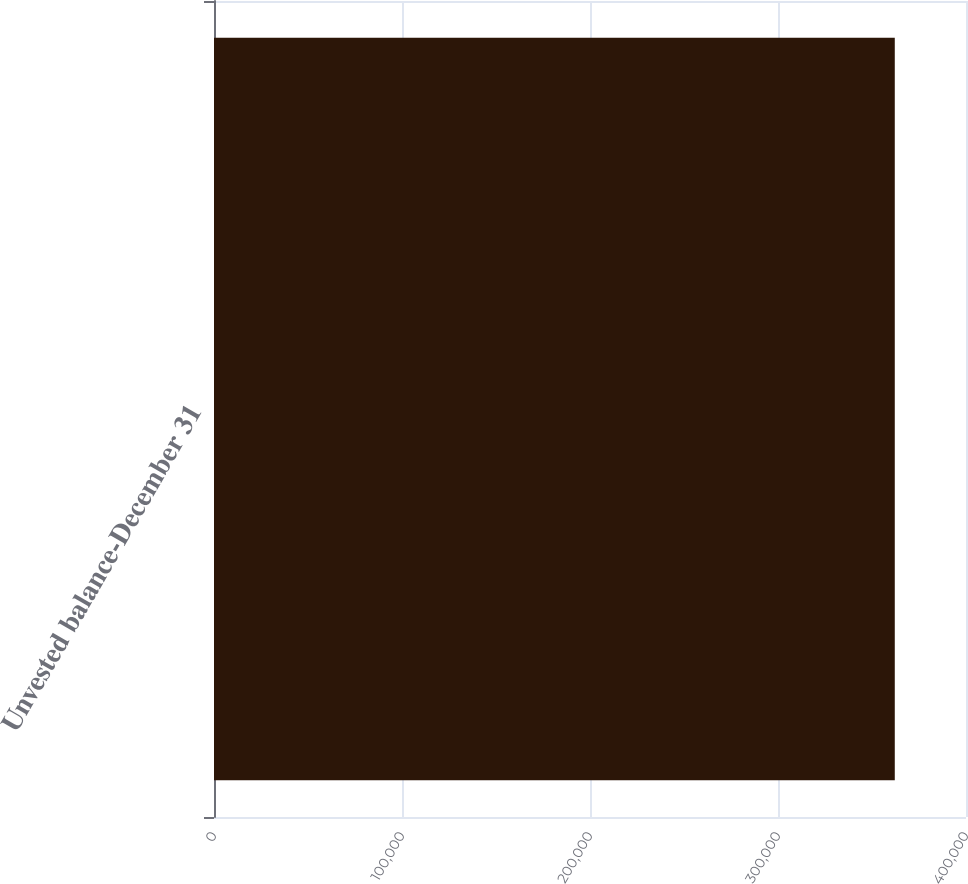<chart> <loc_0><loc_0><loc_500><loc_500><bar_chart><fcel>Unvested balance-December 31<nl><fcel>362119<nl></chart> 